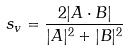<formula> <loc_0><loc_0><loc_500><loc_500>s _ { v } = \frac { 2 | A \cdot B | } { | A | ^ { 2 } + | B | ^ { 2 } }</formula> 